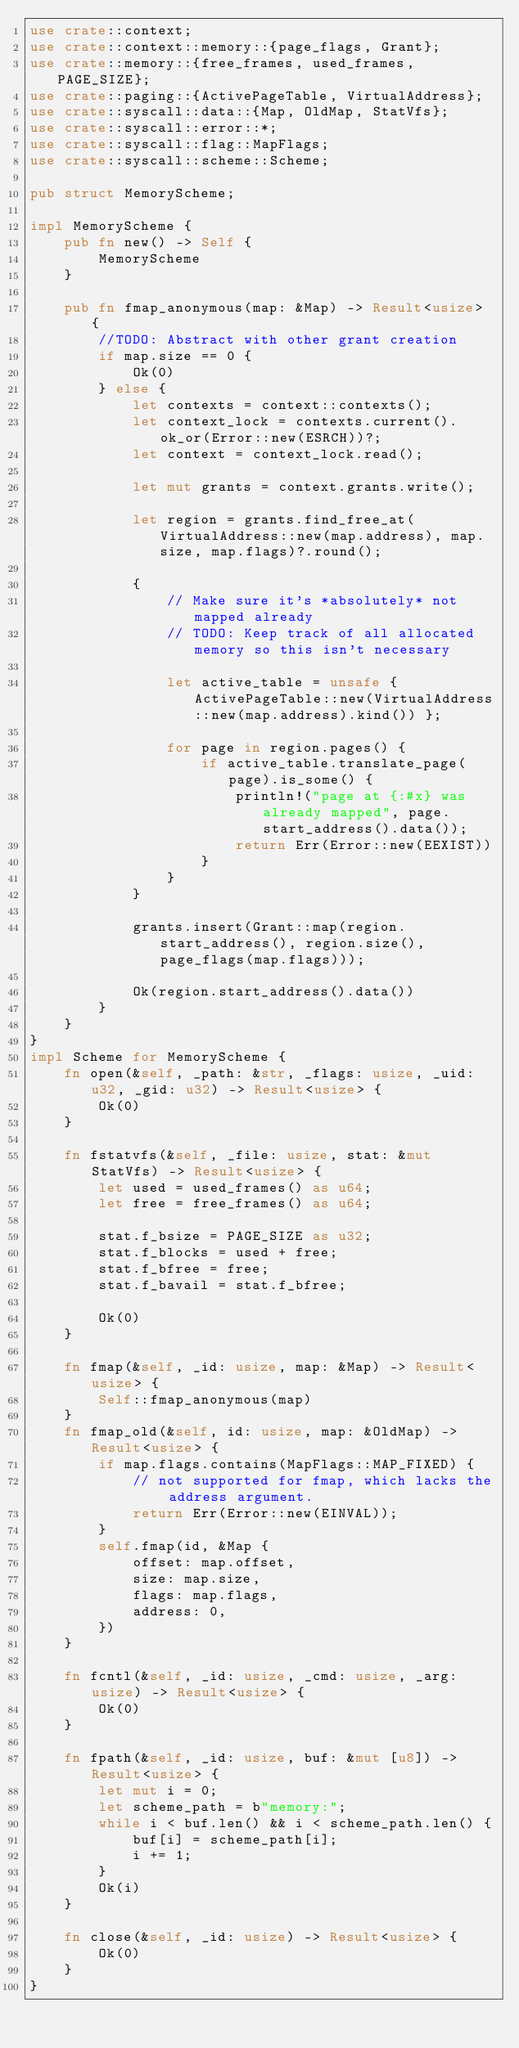Convert code to text. <code><loc_0><loc_0><loc_500><loc_500><_Rust_>use crate::context;
use crate::context::memory::{page_flags, Grant};
use crate::memory::{free_frames, used_frames, PAGE_SIZE};
use crate::paging::{ActivePageTable, VirtualAddress};
use crate::syscall::data::{Map, OldMap, StatVfs};
use crate::syscall::error::*;
use crate::syscall::flag::MapFlags;
use crate::syscall::scheme::Scheme;

pub struct MemoryScheme;

impl MemoryScheme {
    pub fn new() -> Self {
        MemoryScheme
    }

    pub fn fmap_anonymous(map: &Map) -> Result<usize> {
        //TODO: Abstract with other grant creation
        if map.size == 0 {
            Ok(0)
        } else {
            let contexts = context::contexts();
            let context_lock = contexts.current().ok_or(Error::new(ESRCH))?;
            let context = context_lock.read();

            let mut grants = context.grants.write();

            let region = grants.find_free_at(VirtualAddress::new(map.address), map.size, map.flags)?.round();

            {
                // Make sure it's *absolutely* not mapped already
                // TODO: Keep track of all allocated memory so this isn't necessary

                let active_table = unsafe { ActivePageTable::new(VirtualAddress::new(map.address).kind()) };

                for page in region.pages() {
                    if active_table.translate_page(page).is_some() {
                        println!("page at {:#x} was already mapped", page.start_address().data());
                        return Err(Error::new(EEXIST))
                    }
                }
            }

            grants.insert(Grant::map(region.start_address(), region.size(), page_flags(map.flags)));

            Ok(region.start_address().data())
        }
    }
}
impl Scheme for MemoryScheme {
    fn open(&self, _path: &str, _flags: usize, _uid: u32, _gid: u32) -> Result<usize> {
        Ok(0)
    }

    fn fstatvfs(&self, _file: usize, stat: &mut StatVfs) -> Result<usize> {
        let used = used_frames() as u64;
        let free = free_frames() as u64;

        stat.f_bsize = PAGE_SIZE as u32;
        stat.f_blocks = used + free;
        stat.f_bfree = free;
        stat.f_bavail = stat.f_bfree;

        Ok(0)
    }

    fn fmap(&self, _id: usize, map: &Map) -> Result<usize> {
        Self::fmap_anonymous(map)
    }
    fn fmap_old(&self, id: usize, map: &OldMap) -> Result<usize> {
        if map.flags.contains(MapFlags::MAP_FIXED) {
            // not supported for fmap, which lacks the address argument.
            return Err(Error::new(EINVAL));
        }
        self.fmap(id, &Map {
            offset: map.offset,
            size: map.size,
            flags: map.flags,
            address: 0,
        })
    }

    fn fcntl(&self, _id: usize, _cmd: usize, _arg: usize) -> Result<usize> {
        Ok(0)
    }

    fn fpath(&self, _id: usize, buf: &mut [u8]) -> Result<usize> {
        let mut i = 0;
        let scheme_path = b"memory:";
        while i < buf.len() && i < scheme_path.len() {
            buf[i] = scheme_path[i];
            i += 1;
        }
        Ok(i)
    }

    fn close(&self, _id: usize) -> Result<usize> {
        Ok(0)
    }
}
</code> 